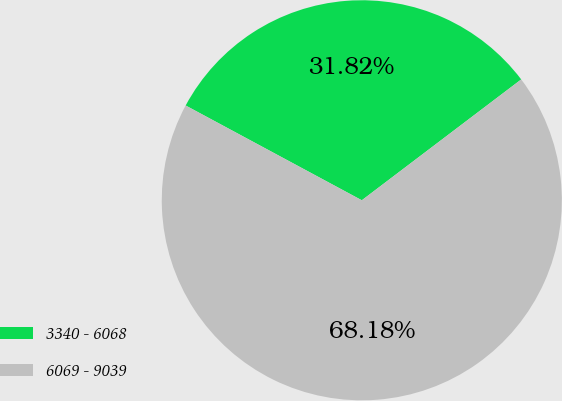Convert chart. <chart><loc_0><loc_0><loc_500><loc_500><pie_chart><fcel>3340 - 6068<fcel>6069 - 9039<nl><fcel>31.82%<fcel>68.18%<nl></chart> 